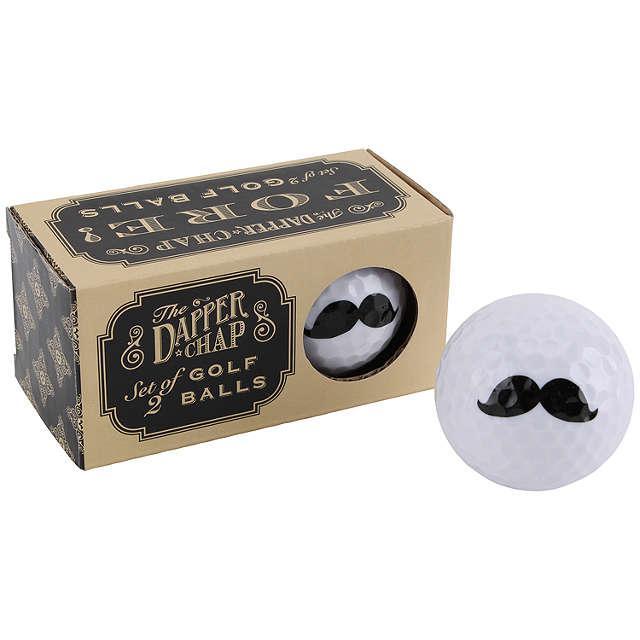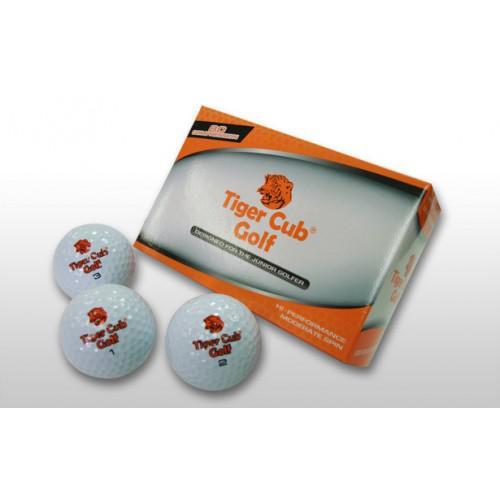The first image is the image on the left, the second image is the image on the right. For the images shown, is this caption "An image shows one brown sack next to a pair of balls." true? Answer yes or no. No. The first image is the image on the left, the second image is the image on the right. For the images shown, is this caption "There are exactly 4 golf balls." true? Answer yes or no. No. 